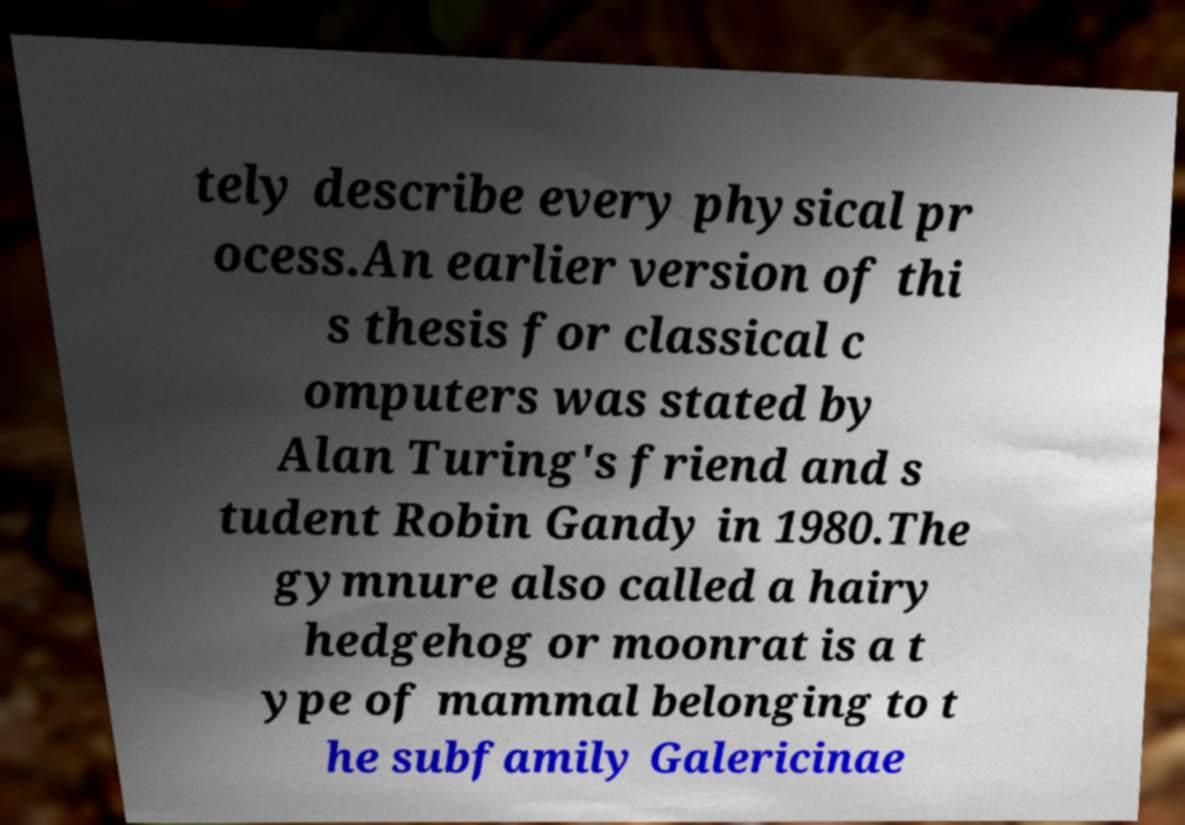For documentation purposes, I need the text within this image transcribed. Could you provide that? tely describe every physical pr ocess.An earlier version of thi s thesis for classical c omputers was stated by Alan Turing's friend and s tudent Robin Gandy in 1980.The gymnure also called a hairy hedgehog or moonrat is a t ype of mammal belonging to t he subfamily Galericinae 